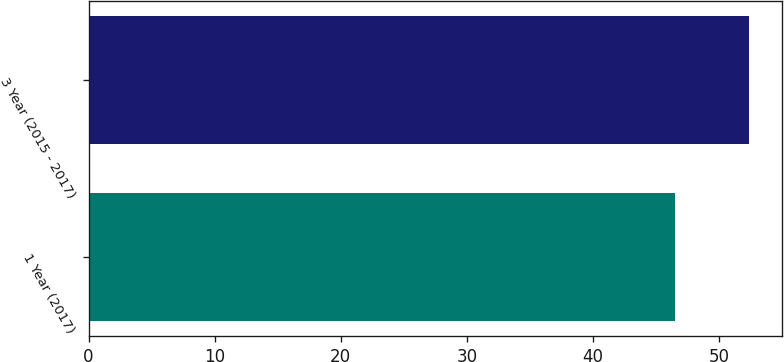Convert chart. <chart><loc_0><loc_0><loc_500><loc_500><bar_chart><fcel>1 Year (2017)<fcel>3 Year (2015 - 2017)<nl><fcel>46.5<fcel>52.4<nl></chart> 